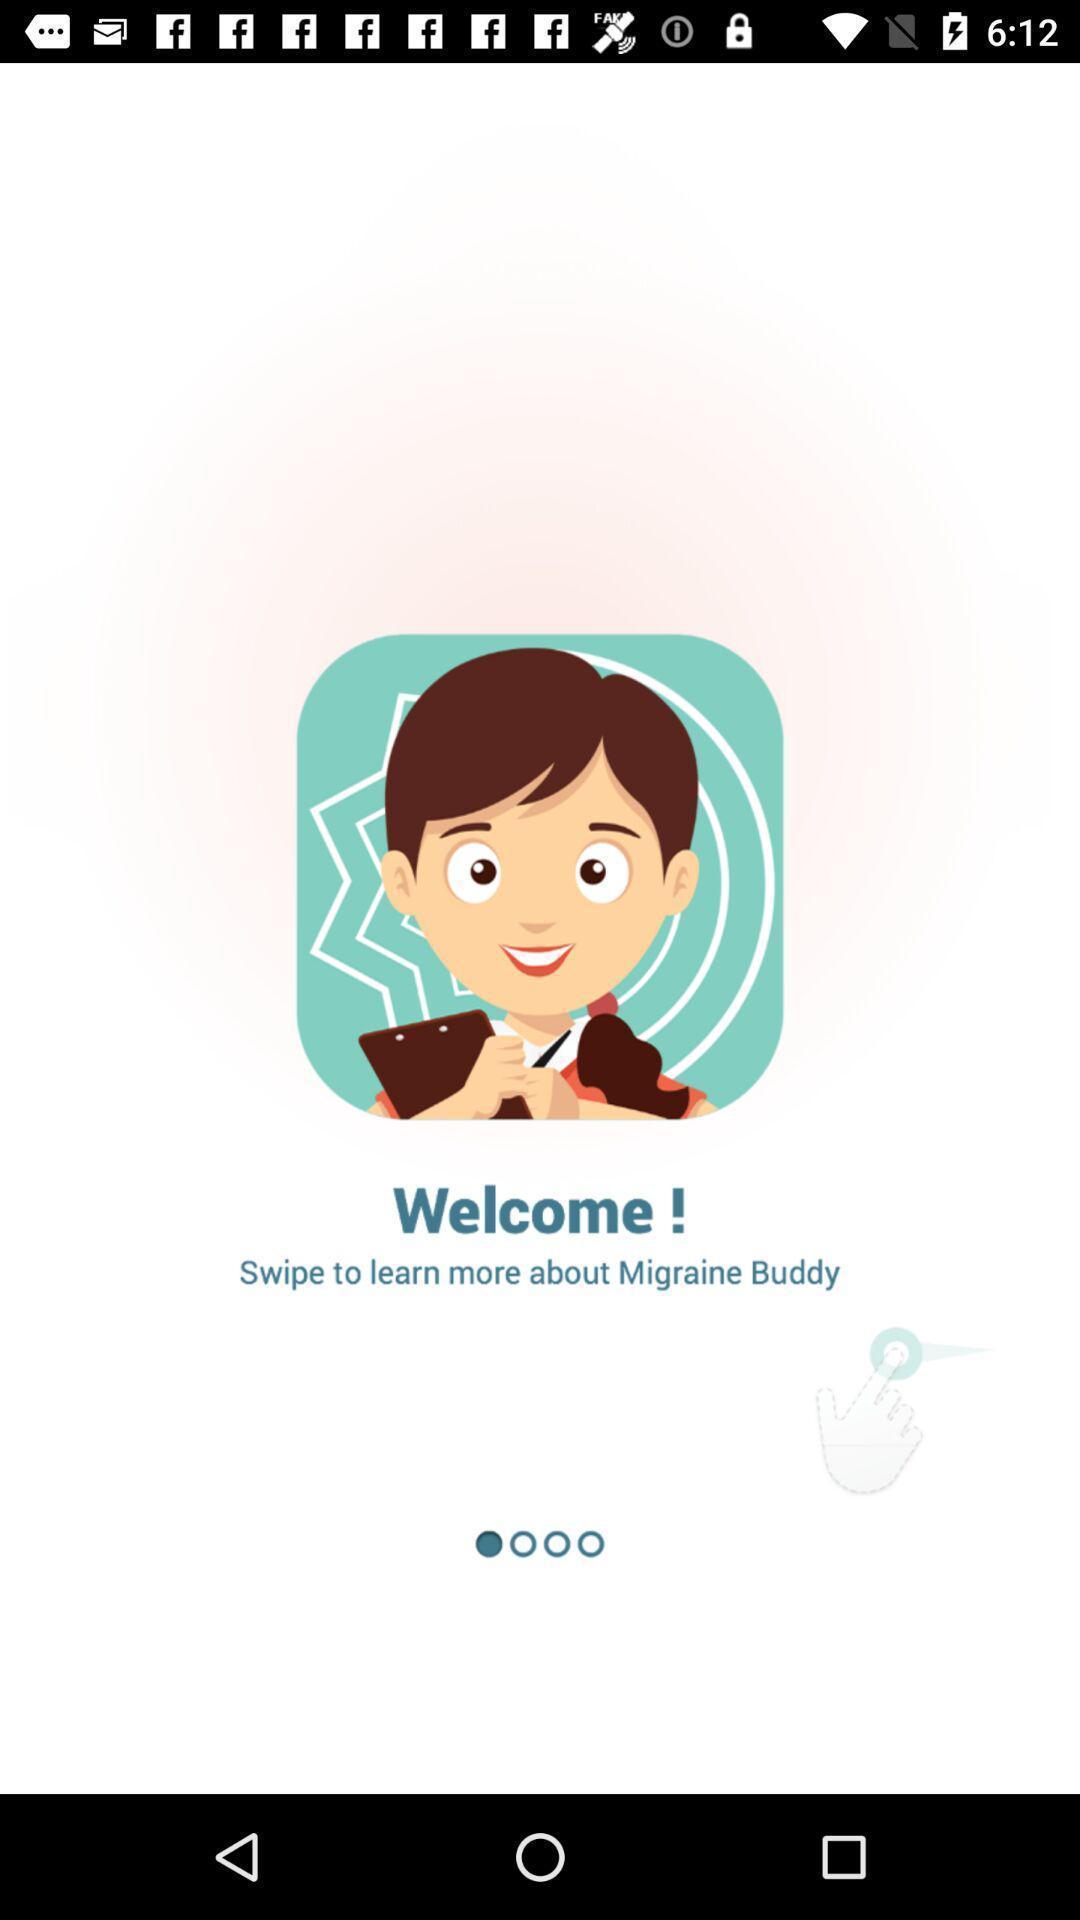Tell me what you see in this picture. Welcome page. 